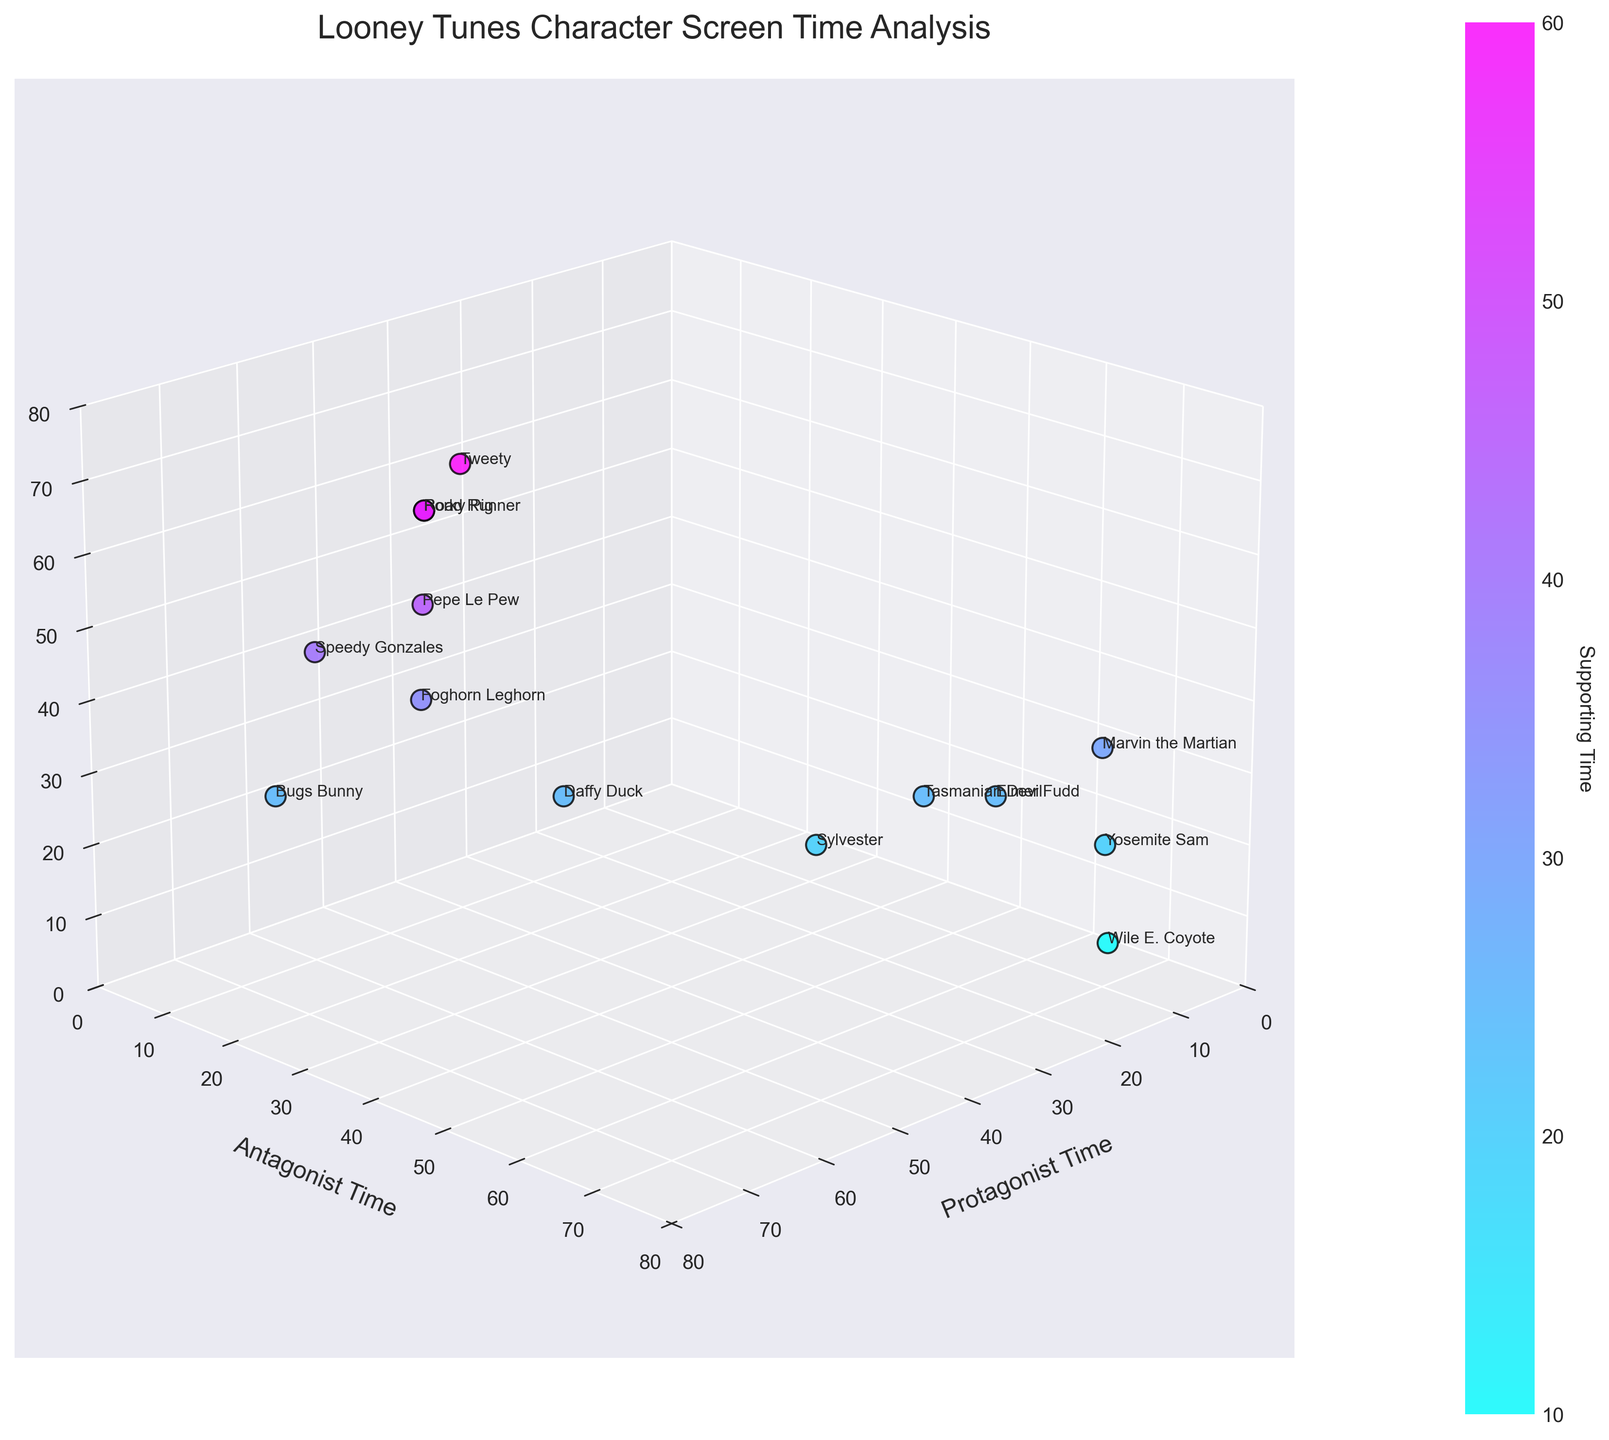What’s the title of the 3D scatter plot? The title is located at the top center of the figure. It provides a concise description of what the plot represents.
Answer: Looney Tunes Character Screen Time Analysis Which axis represents the antagonist time? Each axis is labeled accordingly to represent a specific dimension of the data. The y-axis, or the second axis from the left, is labeled for antagonist time.
Answer: y-axis How does the supporting time of Bugs Bunny compare to Daffy Duck’s supporting time? Bugs Bunny has a supporting time of 25, identifiable by locating Bugs Bunny's label near the z-value of 25. Daffy Duck has a supporting time of 25, which means both characters have equal supporting times.
Answer: Equal Which character has the highest protagonist time? The character with the highest protagonist time will be the furthest point along the x-axis. By examining this axis, Bugs Bunny, with a protagonist time of 65, has the highest value.
Answer: Bugs Bunny What are the axis limits for protagonist time, antagonist time, and supporting time? By observing the plot's axes, the limits or range for each axis can be seen. The axes are limited to a range from 0 to 80.
Answer: 0 to 80 Which character has the highest antagonist time and how much is it? By locating the point furthest along the y-axis, Wile E. Coyote, with an antagonist time of 75, stands out as having the highest value.
Answer: Wile E. Coyote, 75 Compare the protagonist and antagonist times for Yosemite Sam. Which is higher? The plot shows Yosemite Sam with a protagonist time of 10 and an antagonist time of 70. By comparing these figures, the antagonist time is significantly higher.
Answer: Antagonist time What is the average protagonist time for Bugs Bunny, Daffy Duck, and Tweety? Sum the protagonist times of Bugs Bunny (65), Daffy Duck (45), and Tweety (35), and divide by 3. Calculation: (65 + 45 + 35) / 3 = 145 / 3 ≈ 48.33
Answer: 48.33 Which character is closest to having equal times in all three roles? Examining the points that are nearly equidistant from the three axes, Daffy Duck has a protagonist time of 45, antagonist time of 30, and supporting time of 25, which are relatively close in value compared to other characters.
Answer: Daffy Duck 